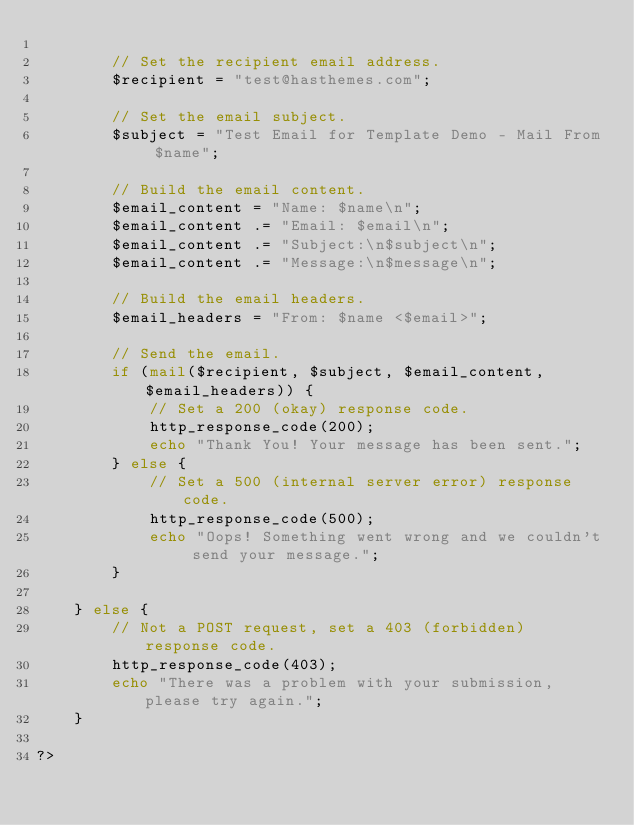Convert code to text. <code><loc_0><loc_0><loc_500><loc_500><_PHP_> 
        // Set the recipient email address.
        $recipient = "test@hasthemes.com";
 
        // Set the email subject.
        $subject = "Test Email for Template Demo - Mail From $name";
 
        // Build the email content.
        $email_content = "Name: $name\n";
        $email_content .= "Email: $email\n";
        $email_content .= "Subject:\n$subject\n";
        $email_content .= "Message:\n$message\n";
 
        // Build the email headers.
        $email_headers = "From: $name <$email>";
 
        // Send the email.
        if (mail($recipient, $subject, $email_content, $email_headers)) {
            // Set a 200 (okay) response code.
            http_response_code(200);
            echo "Thank You! Your message has been sent.";
        } else {
            // Set a 500 (internal server error) response code.
            http_response_code(500);
            echo "Oops! Something went wrong and we couldn't send your message.";
        }
 
    } else {
        // Not a POST request, set a 403 (forbidden) response code.
        http_response_code(403);
        echo "There was a problem with your submission, please try again.";
    }
 
?></code> 